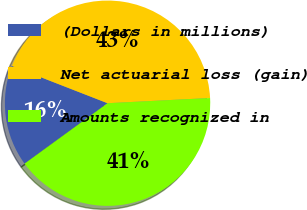Convert chart to OTSL. <chart><loc_0><loc_0><loc_500><loc_500><pie_chart><fcel>(Dollars in millions)<fcel>Net actuarial loss (gain)<fcel>Amounts recognized in<nl><fcel>15.93%<fcel>43.28%<fcel>40.79%<nl></chart> 